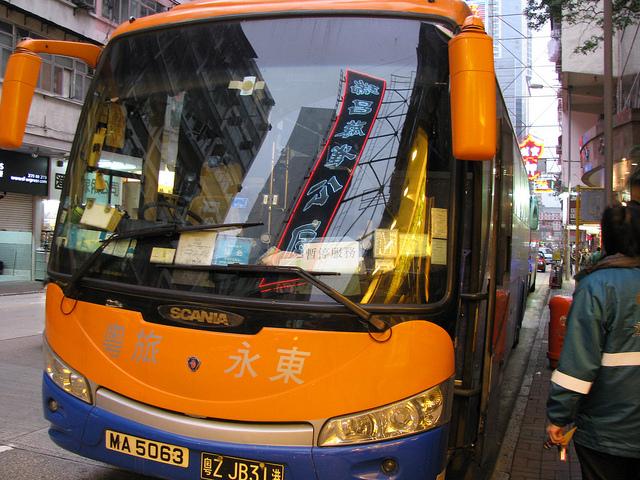What color are the side view mirrors?
Give a very brief answer. Orange. What are all the little stickers and signs in the bus window for?
Quick response, please. Identification. Was this picture taken in the United States?
Concise answer only. No. 